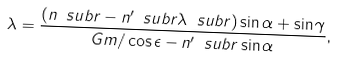Convert formula to latex. <formula><loc_0><loc_0><loc_500><loc_500>\lambda = \frac { ( n \ s u b { r } - n ^ { \prime } \ s u b { r } \lambda \ s u b { r } ) \sin \alpha + \sin \gamma } { G m / \cos \epsilon - n ^ { \prime } \ s u b { r } \sin \alpha } ,</formula> 